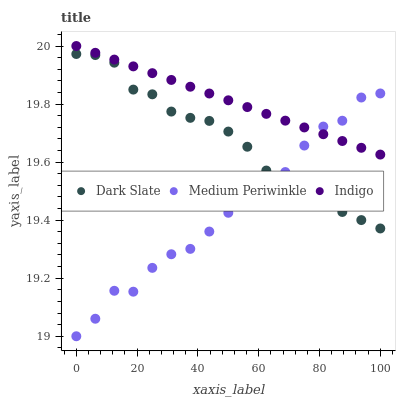Does Medium Periwinkle have the minimum area under the curve?
Answer yes or no. Yes. Does Indigo have the maximum area under the curve?
Answer yes or no. Yes. Does Indigo have the minimum area under the curve?
Answer yes or no. No. Does Medium Periwinkle have the maximum area under the curve?
Answer yes or no. No. Is Indigo the smoothest?
Answer yes or no. Yes. Is Medium Periwinkle the roughest?
Answer yes or no. Yes. Is Medium Periwinkle the smoothest?
Answer yes or no. No. Is Indigo the roughest?
Answer yes or no. No. Does Medium Periwinkle have the lowest value?
Answer yes or no. Yes. Does Indigo have the lowest value?
Answer yes or no. No. Does Indigo have the highest value?
Answer yes or no. Yes. Does Medium Periwinkle have the highest value?
Answer yes or no. No. Is Dark Slate less than Indigo?
Answer yes or no. Yes. Is Indigo greater than Dark Slate?
Answer yes or no. Yes. Does Medium Periwinkle intersect Indigo?
Answer yes or no. Yes. Is Medium Periwinkle less than Indigo?
Answer yes or no. No. Is Medium Periwinkle greater than Indigo?
Answer yes or no. No. Does Dark Slate intersect Indigo?
Answer yes or no. No. 